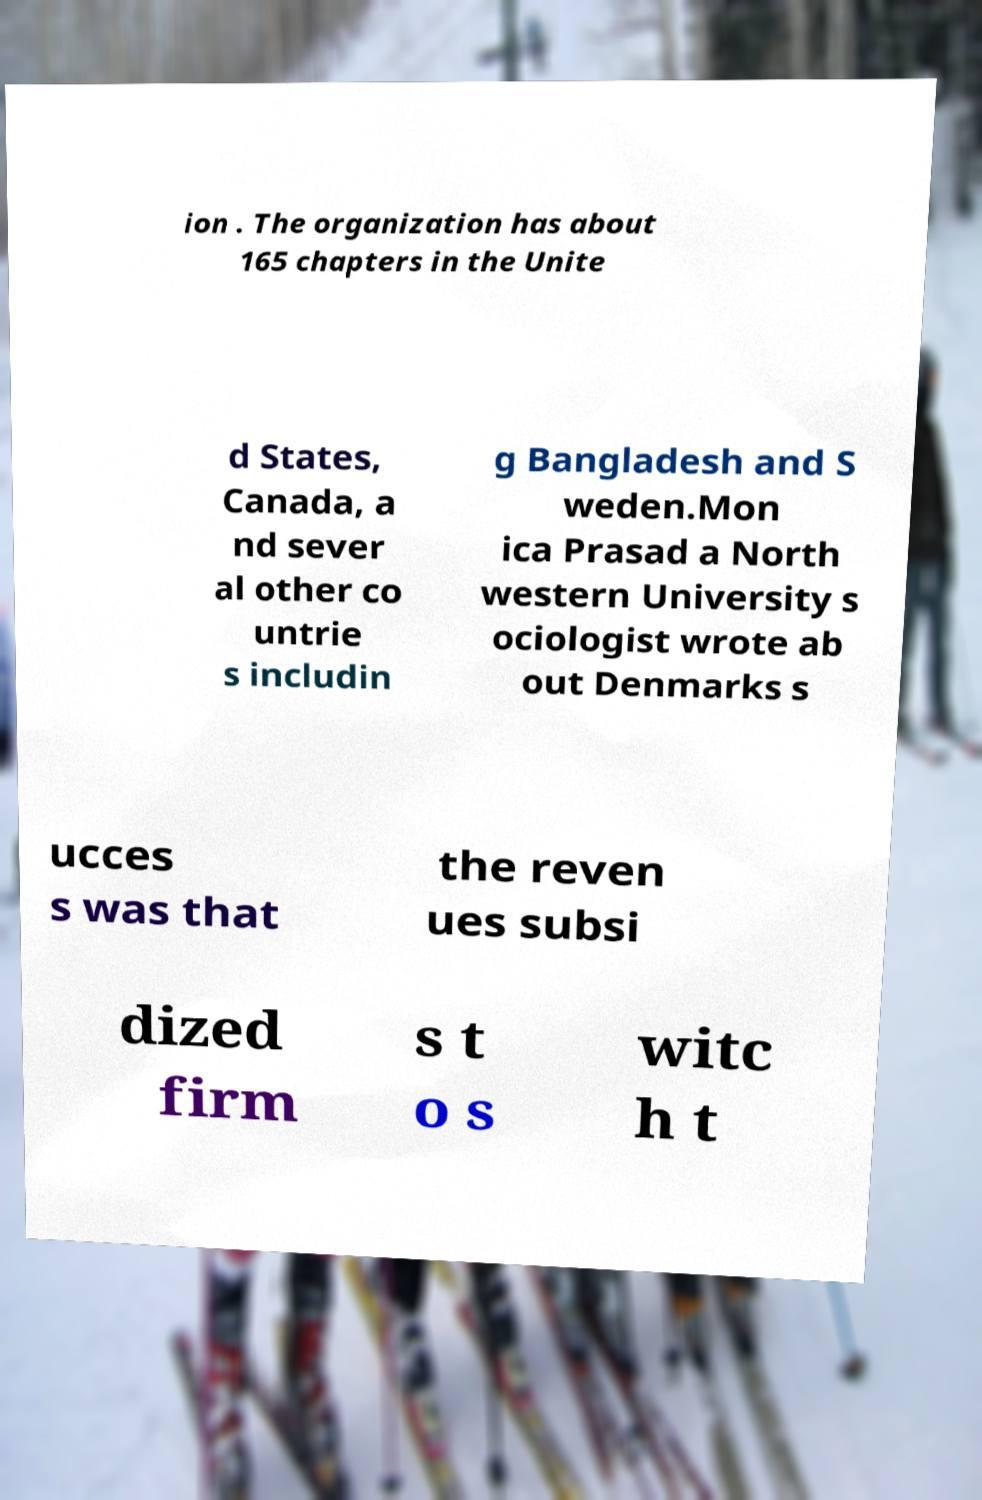Can you read and provide the text displayed in the image?This photo seems to have some interesting text. Can you extract and type it out for me? ion . The organization has about 165 chapters in the Unite d States, Canada, a nd sever al other co untrie s includin g Bangladesh and S weden.Mon ica Prasad a North western University s ociologist wrote ab out Denmarks s ucces s was that the reven ues subsi dized firm s t o s witc h t 